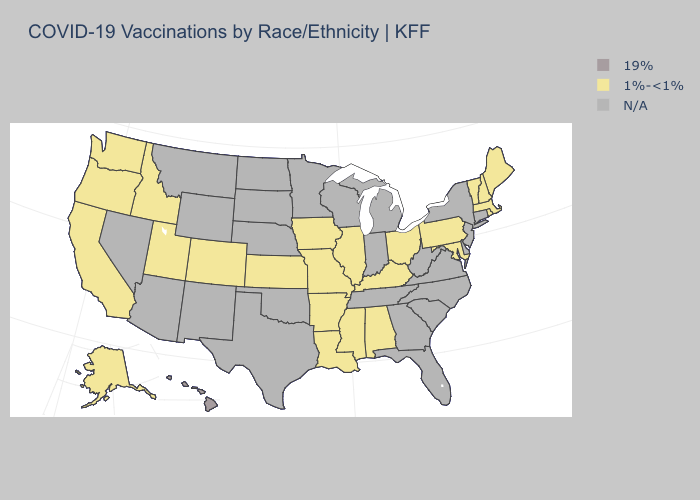Name the states that have a value in the range 1%-<1%?
Short answer required. Alabama, Alaska, Arkansas, California, Colorado, Idaho, Illinois, Iowa, Kansas, Kentucky, Louisiana, Maine, Maryland, Massachusetts, Mississippi, Missouri, New Hampshire, Ohio, Oregon, Pennsylvania, Rhode Island, Utah, Vermont, Washington. Which states hav the highest value in the South?
Write a very short answer. Alabama, Arkansas, Kentucky, Louisiana, Maryland, Mississippi. Among the states that border Colorado , which have the lowest value?
Answer briefly. Kansas, Utah. Which states have the lowest value in the USA?
Answer briefly. Alabama, Alaska, Arkansas, California, Colorado, Idaho, Illinois, Iowa, Kansas, Kentucky, Louisiana, Maine, Maryland, Massachusetts, Mississippi, Missouri, New Hampshire, Ohio, Oregon, Pennsylvania, Rhode Island, Utah, Vermont, Washington. Name the states that have a value in the range N/A?
Give a very brief answer. Arizona, Connecticut, Delaware, Florida, Georgia, Indiana, Michigan, Minnesota, Montana, Nebraska, Nevada, New Jersey, New Mexico, New York, North Carolina, North Dakota, Oklahoma, South Carolina, South Dakota, Tennessee, Texas, Virginia, West Virginia, Wisconsin, Wyoming. Name the states that have a value in the range 1%-<1%?
Quick response, please. Alabama, Alaska, Arkansas, California, Colorado, Idaho, Illinois, Iowa, Kansas, Kentucky, Louisiana, Maine, Maryland, Massachusetts, Mississippi, Missouri, New Hampshire, Ohio, Oregon, Pennsylvania, Rhode Island, Utah, Vermont, Washington. What is the value of Oregon?
Short answer required. 1%-<1%. What is the value of Alabama?
Be succinct. 1%-<1%. Does Washington have the highest value in the West?
Concise answer only. No. What is the highest value in states that border Maryland?
Quick response, please. 1%-<1%. 